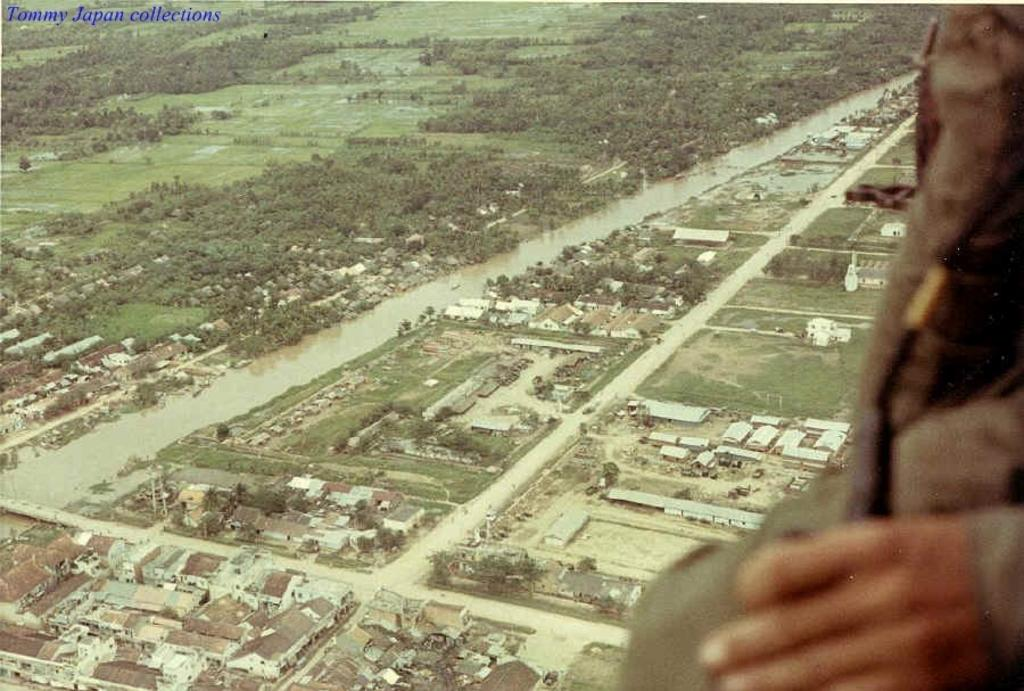What type of landscape is depicted in the image? The image contains fields with grass and trees. What type of terrain is visible in the image? The image contains land. Are there any structures visible in the image? Yes, there are houses in the image. From what perspective is the image likely taken? The image is likely viewed from a high vantage point, possibly from the sky. What type of feather can be seen floating in the air in the image? There is no feather visible in the image; it only contains fields, trees, land, houses, and a high vantage point. Can you tell me how many quince trees are present in the image? There is no mention of quince trees in the image; it only contains fields, trees, land, houses, and a high vantage point. 